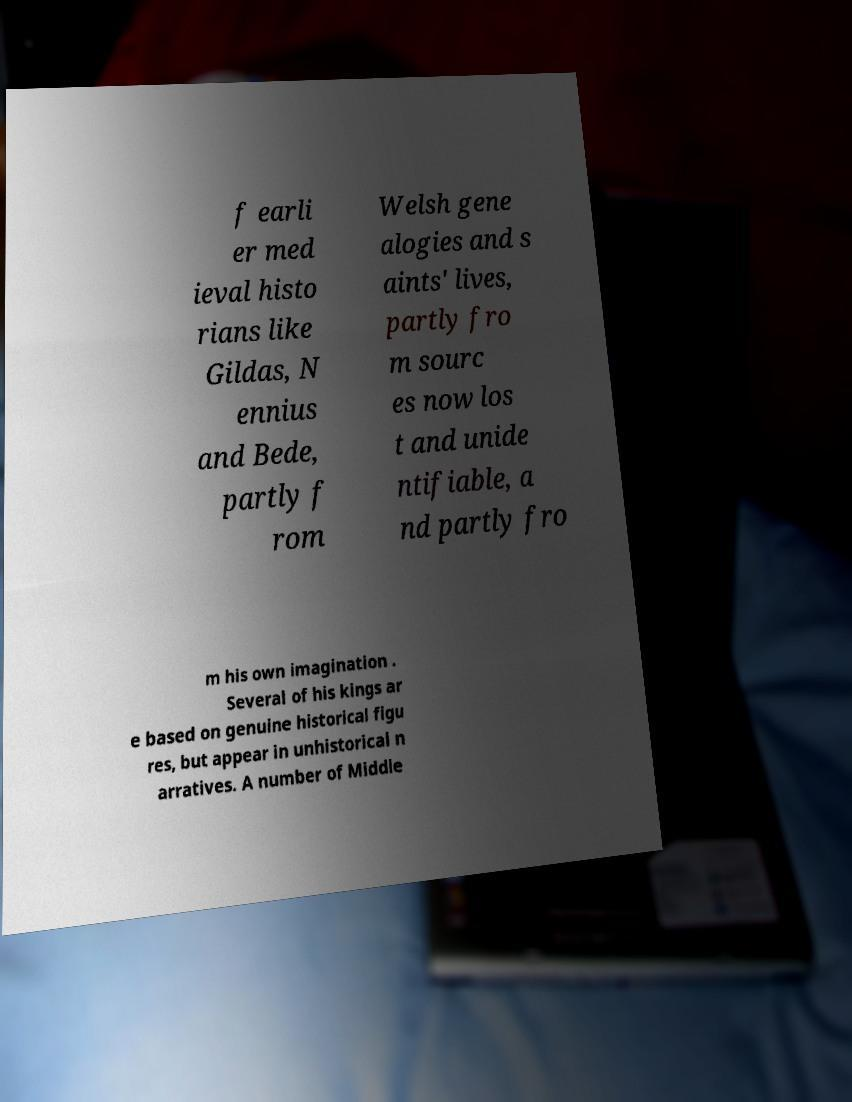Please read and relay the text visible in this image. What does it say? f earli er med ieval histo rians like Gildas, N ennius and Bede, partly f rom Welsh gene alogies and s aints' lives, partly fro m sourc es now los t and unide ntifiable, a nd partly fro m his own imagination . Several of his kings ar e based on genuine historical figu res, but appear in unhistorical n arratives. A number of Middle 